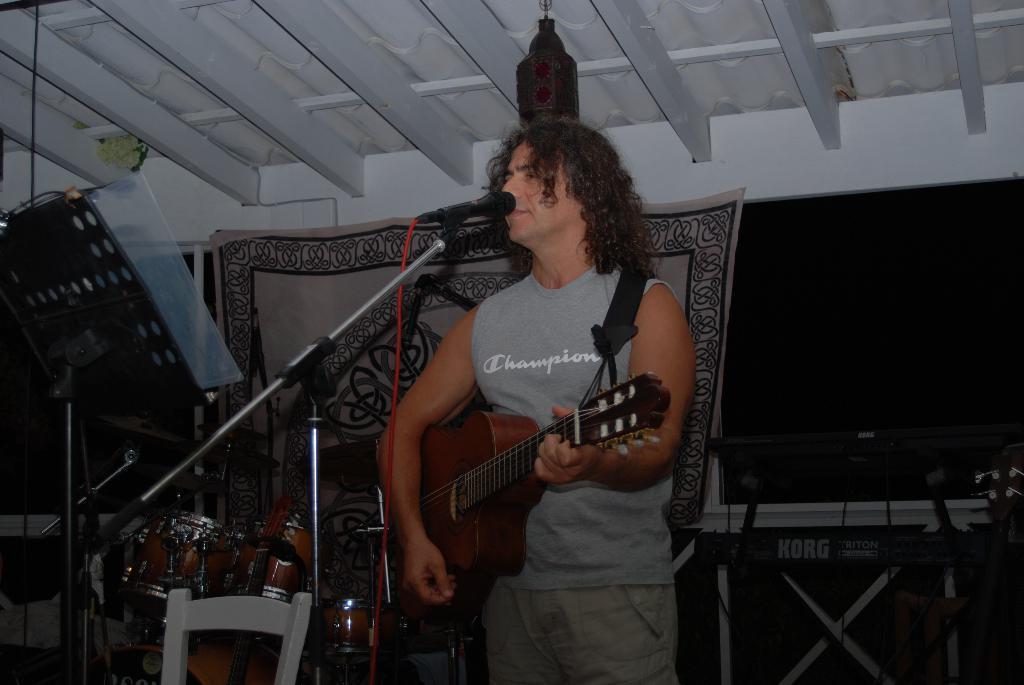Please provide a concise description of this image. In this image I can see a man is standing and holding a guitar. I can also see he is wearing sleeveless t-shirt. Here I can see a mic in front of him and a drum set in the background. I can also see a stand. 